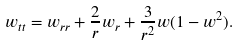Convert formula to latex. <formula><loc_0><loc_0><loc_500><loc_500>w _ { t t } = w _ { r r } + \frac { 2 } { r } w _ { r } + \frac { 3 } { r ^ { 2 } } w ( 1 - w ^ { 2 } ) .</formula> 